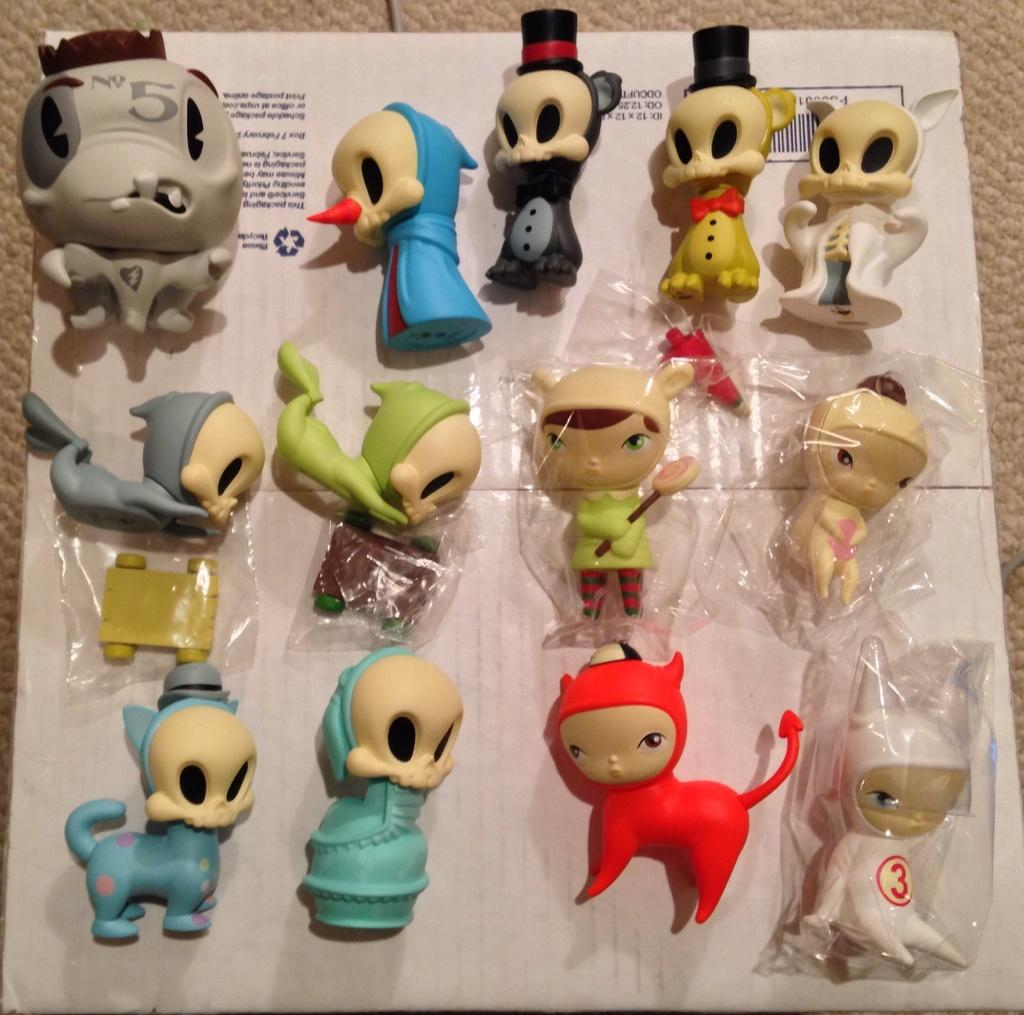What is the main subject of the image? The main subject of the image is different types of toys. Where are the toys located in the image? The toys are in the center of the image. What else can be seen in the background of the image? There is a board in the background of the image. How does the frame of the image affect the toys' appearance? There is no frame present in the image, so it does not affect the toys' appearance. 